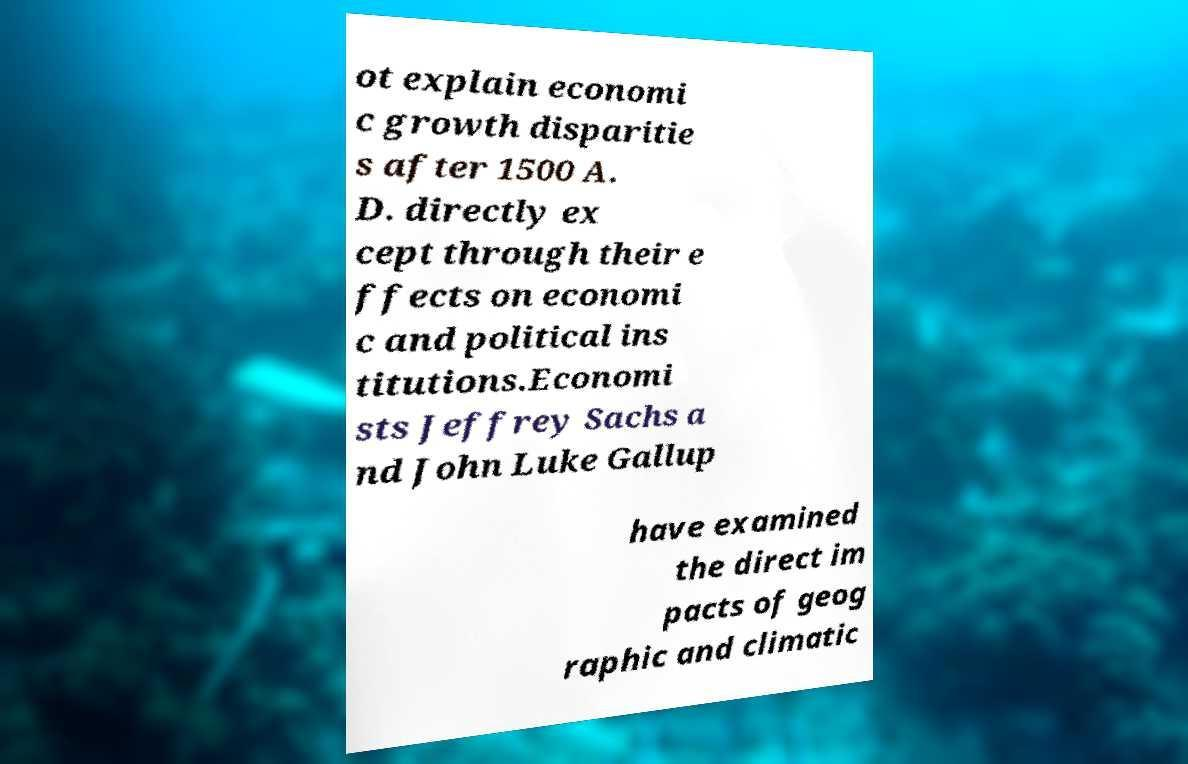There's text embedded in this image that I need extracted. Can you transcribe it verbatim? ot explain economi c growth disparitie s after 1500 A. D. directly ex cept through their e ffects on economi c and political ins titutions.Economi sts Jeffrey Sachs a nd John Luke Gallup have examined the direct im pacts of geog raphic and climatic 